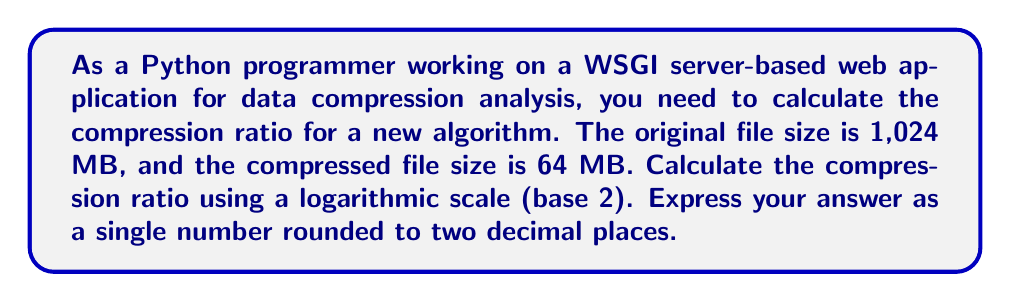Can you solve this math problem? To calculate the compression ratio using a logarithmic scale, we'll use the following formula:

$$\text{Compression Ratio} = \frac{\log_2(\text{Original Size})}{\log_2(\text{Compressed Size})}$$

Let's break it down step-by-step:

1. Original file size: 1,024 MB
2. Compressed file size: 64 MB

3. Calculate $\log_2(\text{Original Size})$:
   $$\log_2(1024) = 10$$
   (Since $2^{10} = 1024$)

4. Calculate $\log_2(\text{Compressed Size})$:
   $$\log_2(64) = 6$$
   (Since $2^6 = 64$)

5. Apply the formula:
   $$\text{Compression Ratio} = \frac{\log_2(1024)}{\log_2(64)} = \frac{10}{6}$$

6. Perform the division:
   $$\frac{10}{6} \approx 1.6666667$$

7. Round to two decimal places:
   $$1.67$$

This logarithmic scale representation of the compression ratio allows for a more intuitive comparison between different compression algorithms, especially when dealing with large file sizes.
Answer: $1.67$ 